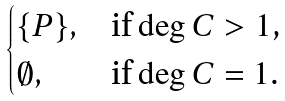Convert formula to latex. <formula><loc_0><loc_0><loc_500><loc_500>\begin{cases} \{ P \} , & \text {if $\deg C > 1$,} \\ \emptyset , & \text {if $\deg C = 1$.} \end{cases}</formula> 